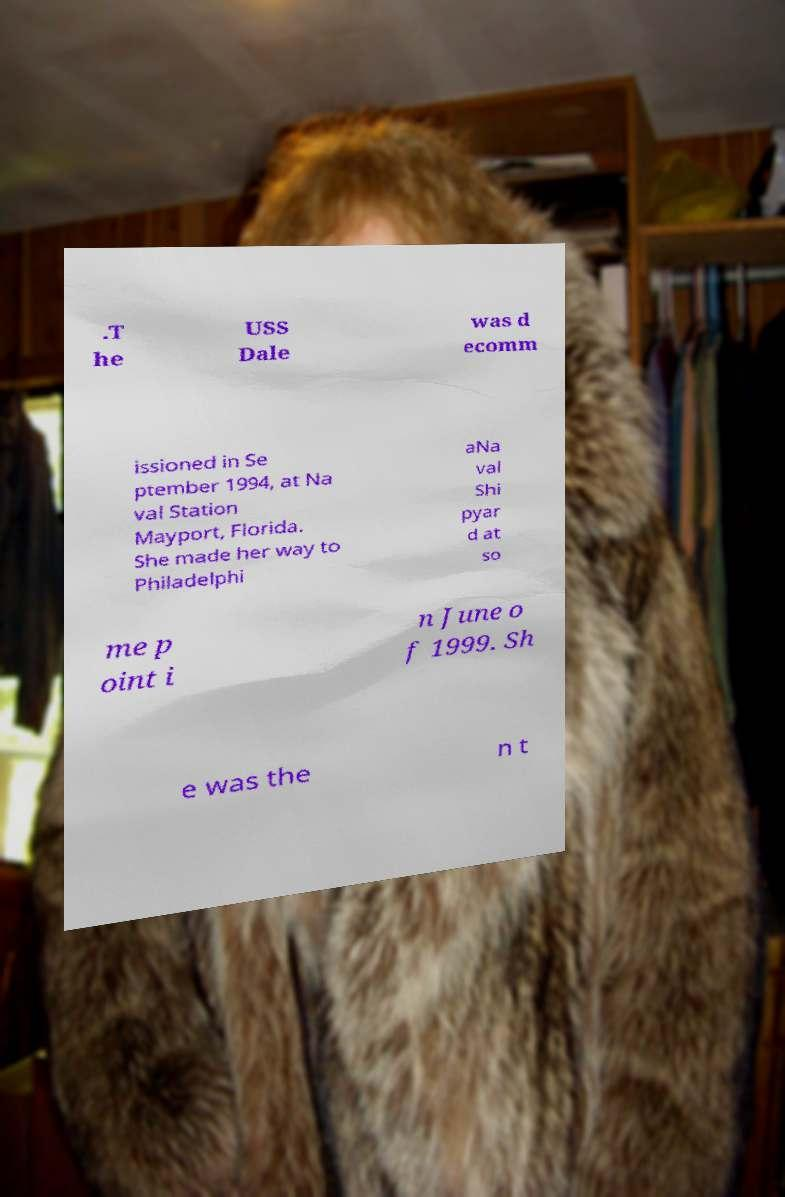For documentation purposes, I need the text within this image transcribed. Could you provide that? .T he USS Dale was d ecomm issioned in Se ptember 1994, at Na val Station Mayport, Florida. She made her way to Philadelphi aNa val Shi pyar d at so me p oint i n June o f 1999. Sh e was the n t 